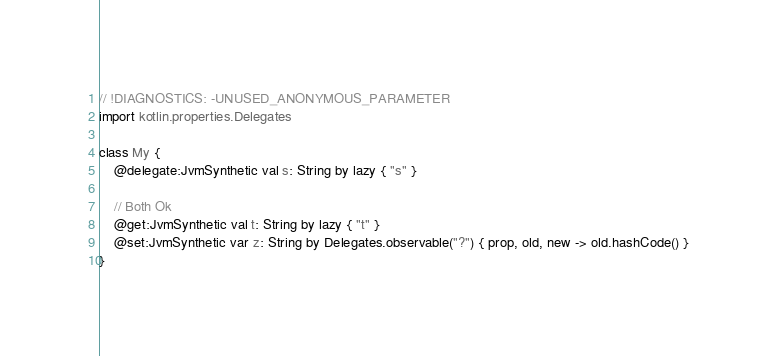<code> <loc_0><loc_0><loc_500><loc_500><_Kotlin_>// !DIAGNOSTICS: -UNUSED_ANONYMOUS_PARAMETER
import kotlin.properties.Delegates

class My {
    @delegate:JvmSynthetic val s: String by lazy { "s" }

    // Both Ok
    @get:JvmSynthetic val t: String by lazy { "t" }
    @set:JvmSynthetic var z: String by Delegates.observable("?") { prop, old, new -> old.hashCode() }
}
</code> 